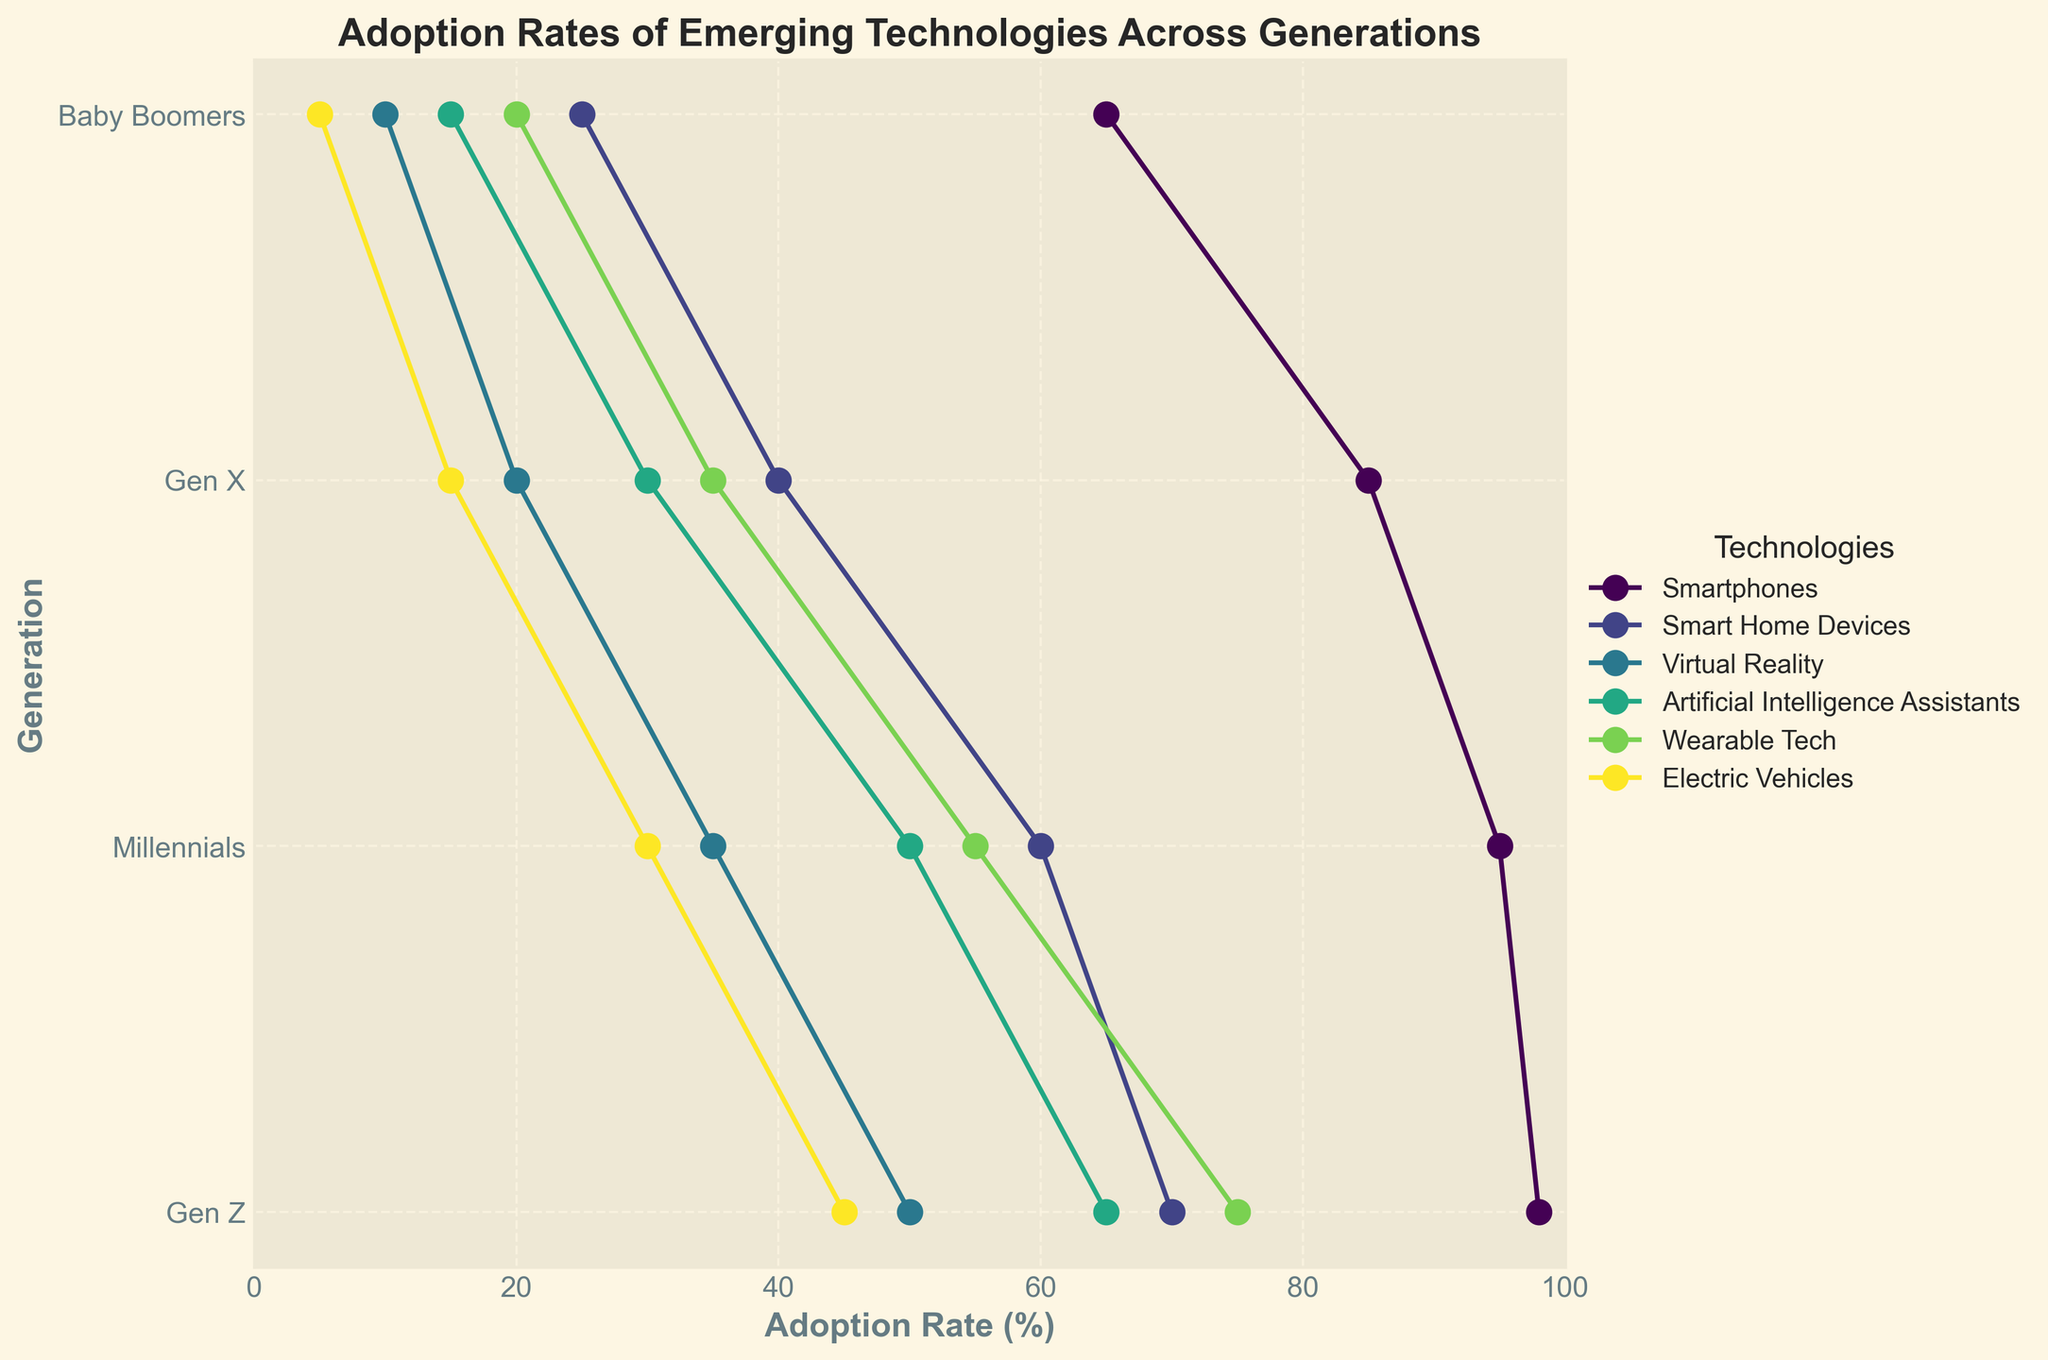What is the title of the figure? The title is typically placed at the top of the figure. "Adoption Rates of Emerging Technologies Across Generations" is clearly displayed as the title.
Answer: Adoption Rates of Emerging Technologies Across Generations Which generation has the highest adoption rate for Smartphones? To find this, look at the values for Smartphones across the generations. Gen Z has the highest value at 98%.
Answer: Gen Z What are the adoption rates for Wearable Tech across all generations? Check the line labeled "Wearable Tech" and note the adoption rates for each generation. The values are Baby Boomers: 20%, Gen X: 35%, Millennials: 55%, Gen Z: 75%.
Answer: Baby Boomers: 20%, Gen X: 35%, Millennials: 55%, Gen Z: 75% Which technology shows the largest adoption rate gap between Baby Boomers and Gen Z? Calculate the difference for each technology between Baby Boomers and Gen Z. Virtual Reality has the largest difference: 50% (Gen Z) - 10% (Baby Boomers) = 40%.
Answer: Virtual Reality What is the average adoption rate of Artificial Intelligence Assistants across the generations? Add the adoption rates for Artificial Intelligence Assistants across all generations (65% + 50% + 30% + 15%) and divide by 4. The calculations show (65 + 50 + 30 + 15) / 4 = 40%.
Answer: 40% How does the adoption rate of Electric Vehicles among Gen X compare to that among Millennials? Compare the values in the chart: Gen X has a 15% adoption rate, and Millennials have a 30% adoption rate. 15% is less than 30%.
Answer: Less than Which generation shows the lowest adoption rate for Smart Home Devices? Look at the values for Smart Home Devices across all generations. Baby Boomers have the lowest adoption rate at 25%.
Answer: Baby Boomers Between Gen Z and Millennials, which generation has a higher adoption rate for Virtual Reality, and by how much? Compare the adoption rates for Virtual Reality. Gen Z has 50%, and Millennials have 35%. The difference is 50% - 35% = 15%.
Answer: Gen Z by 15% What is the general trend in technology adoption rates from Baby Boomers to Gen Z? By examining multiple lines' slopes from left to right (from Baby Boomers to Gen Z), adoption rates generally increase.
Answer: Increases 